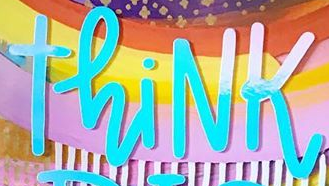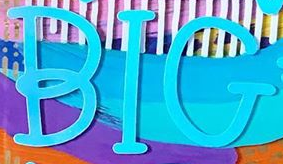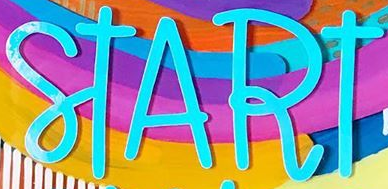Read the text from these images in sequence, separated by a semicolon. ThiNK; BIG; START 